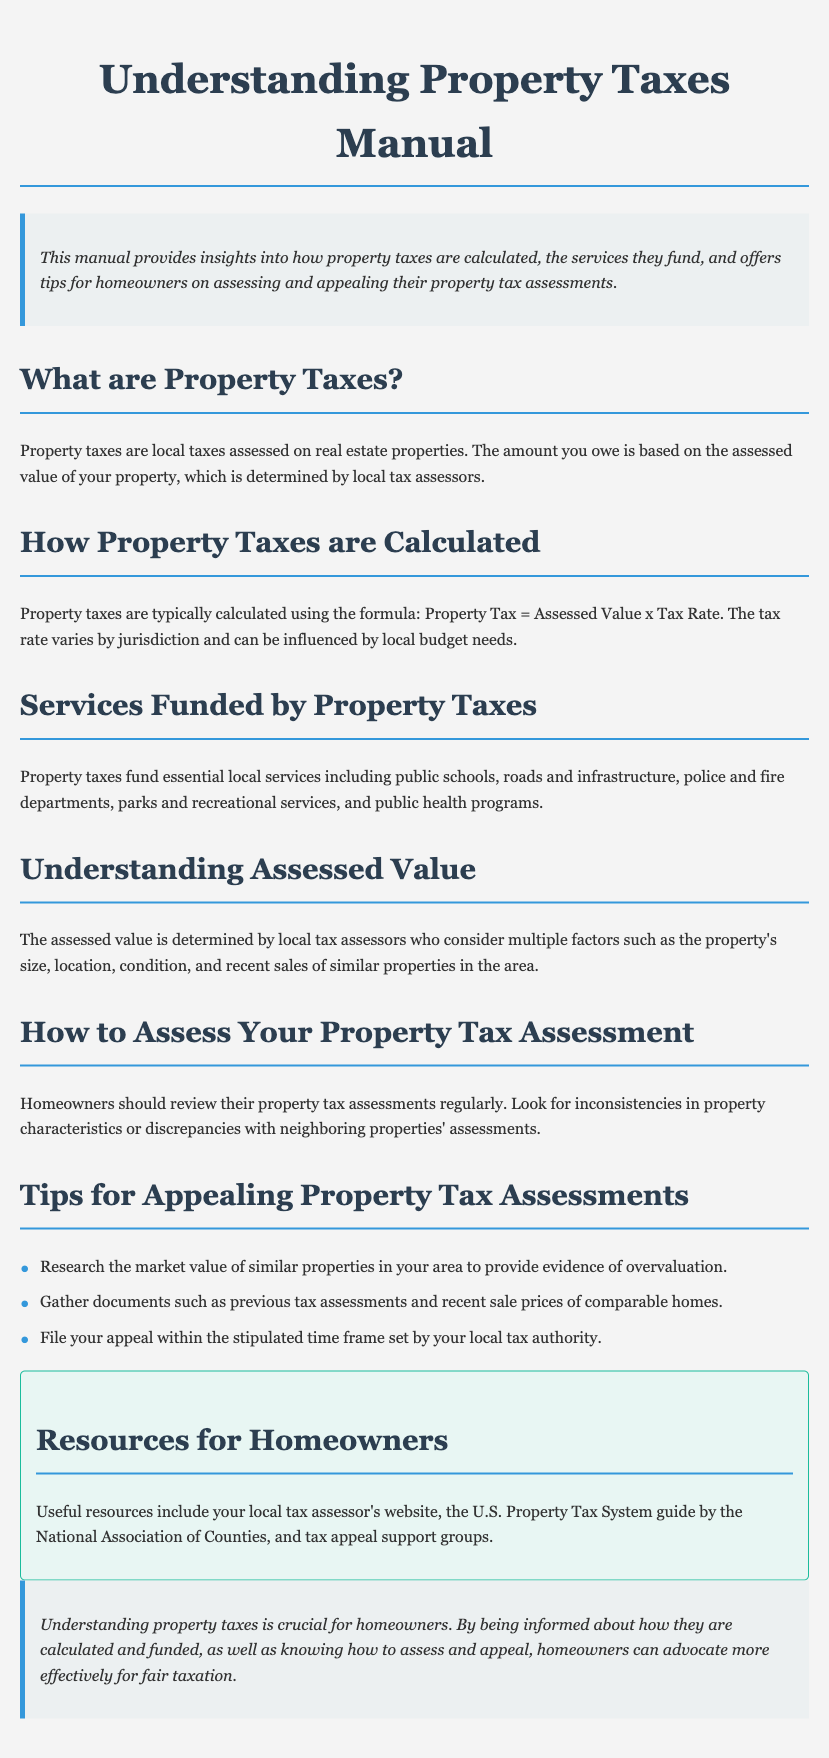What are property taxes? Property taxes are local taxes assessed on real estate properties.
Answer: Local taxes assessed on real estate properties How are property taxes calculated? Property taxes are calculated using the formula: Property Tax = Assessed Value x Tax Rate.
Answer: Assessed Value x Tax Rate What services do property taxes fund? Property taxes fund essential local services including public schools, roads and infrastructure, police and fire departments, parks and recreational services, and public health programs.
Answer: Public schools, roads, police, fire departments, parks, public health What factors determine assessed value? The assessed value is determined by factors such as the property's size, location, condition, and recent sales of similar properties.
Answer: Size, location, condition, recent sales What is one tip for appealing property tax assessments? One tip for appealing property tax assessments is to research the market value of similar properties in your area.
Answer: Research market value of similar properties What should homeowners review regularly? Homeowners should review their property tax assessments regularly.
Answer: Property tax assessments What is a resource for homeowners regarding property taxes? A useful resource for homeowners is their local tax assessor's website.
Answer: Local tax assessor's website What is crucial for homeowners to understand? Understanding property taxes is crucial for homeowners.
Answer: Understanding property taxes 